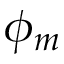Convert formula to latex. <formula><loc_0><loc_0><loc_500><loc_500>\phi _ { m }</formula> 